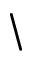Convert formula to latex. <formula><loc_0><loc_0><loc_500><loc_500>\</formula> 